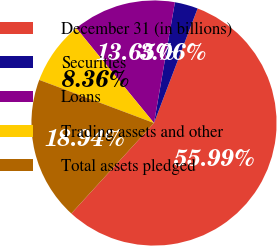<chart> <loc_0><loc_0><loc_500><loc_500><pie_chart><fcel>December 31 (in billions)<fcel>Securities<fcel>Loans<fcel>Trading assets and other<fcel>Total assets pledged<nl><fcel>55.99%<fcel>3.06%<fcel>13.65%<fcel>8.36%<fcel>18.94%<nl></chart> 